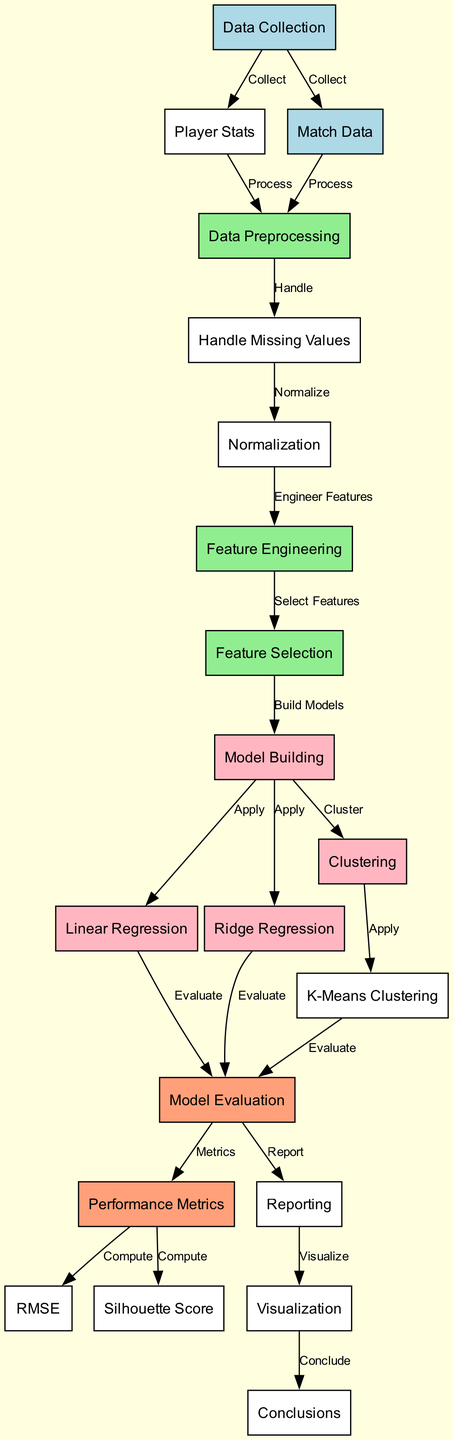What are the two main types of data collected? The diagram indicates that both "Player Stats" and "Match Data" are collected from the "Data Collection" node.
Answer: Player Stats, Match Data How many modeling techniques are applied in the diagram? The diagram shows three modeling techniques: "Linear Regression," "Ridge Regression," and "Clustering." Therefore, the total count is three.
Answer: Three What comes after "Data Preprocessing"? After "Data Preprocessing," the next step is "Missing Values," which is indicated directly as the next node connected with an edge.
Answer: Missing Values Which metric is computed after model evaluation? From the "Performance Metrics" node, both "RMSE" and "Silhouette Score" are computed, but the diagram specifies the next step after "Evaluation" to be "Performance Metrics."
Answer: RMSE, Silhouette Score What is the final step in the diagram? The final node, connected through an edge from "Visualization," is "Conclusions," indicating that conclusions are drawn based on visualization results.
Answer: Conclusions What type of regression is not included in model building? The diagram includes "Linear Regression" and "Ridge Regression" in the "Model Building" section but does not mention any other types of regression, such as "Logistic Regression."
Answer: Logistic Regression What is necessary to handle after preprocessing? The diagram indicates that "Missing Values" must be handled after the "Data Preprocessing" step, confirming that it is essential to address this issue before proceeding further.
Answer: Missing Values What phase follows feature selection? After "Feature Selection," the next phase is "Model Building," where various modelling techniques are applied. This is a seamless transition as shown by the connected edge in the diagram.
Answer: Model Building What method is used for clustering in the diagram? The diagram specifies "K-Means Clustering" as the method applied within the "Clustering" section of the model building process.
Answer: K-Means Clustering 